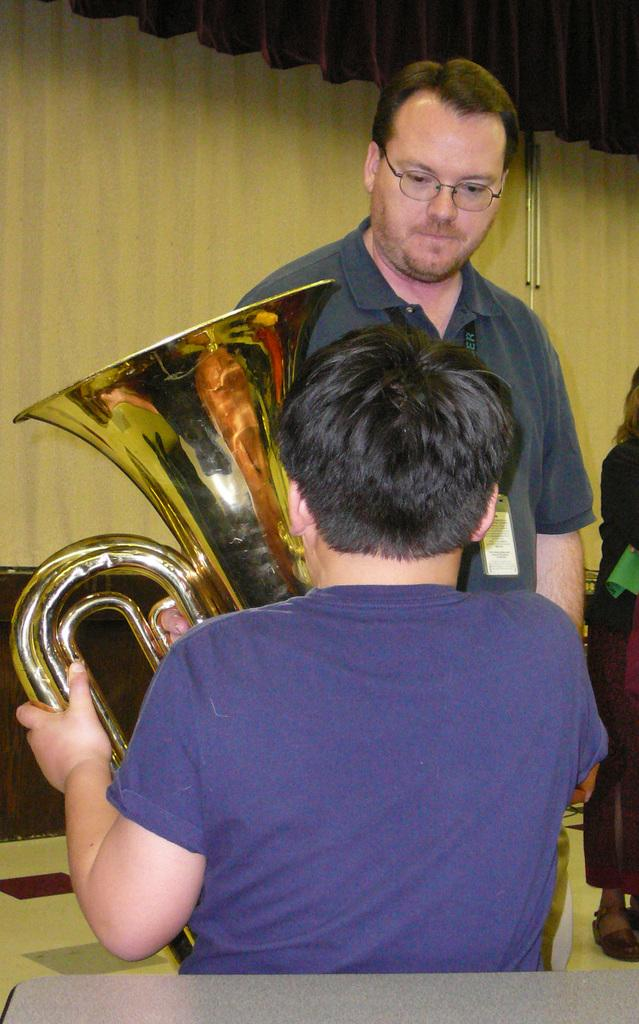Who or what can be seen in the image? There are people in the image. What type of object is present in the image that is related to covering or concealing? There is a curtain in the image. What type of object is present in the image that is related to creating music? There is a musical instrument in the image. What type of bean is present in the image? There is no bean present in the image. What type of war is depicted in the image? There is no war depicted in the image; it features people, a curtain, and a musical instrument. 